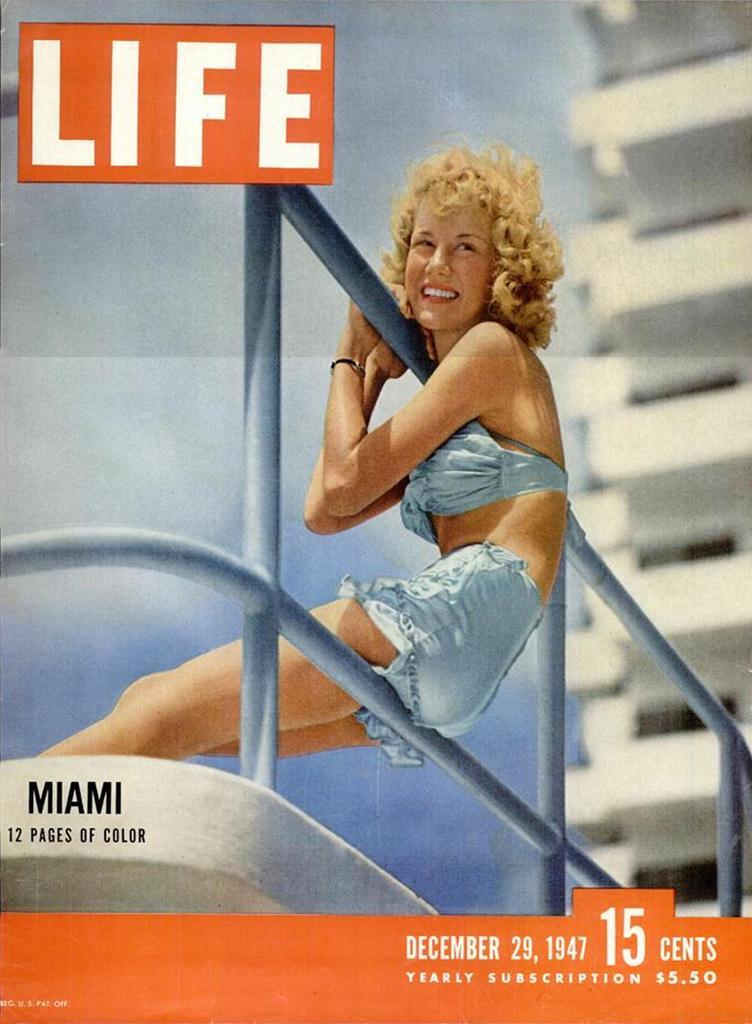In one or two sentences, can you explain what this image depicts? This might be a poster in this image in the center there is one woman, and she is holding a pole and there is a railing. In the background there is a building, at the top and bottom of the image there is text. 